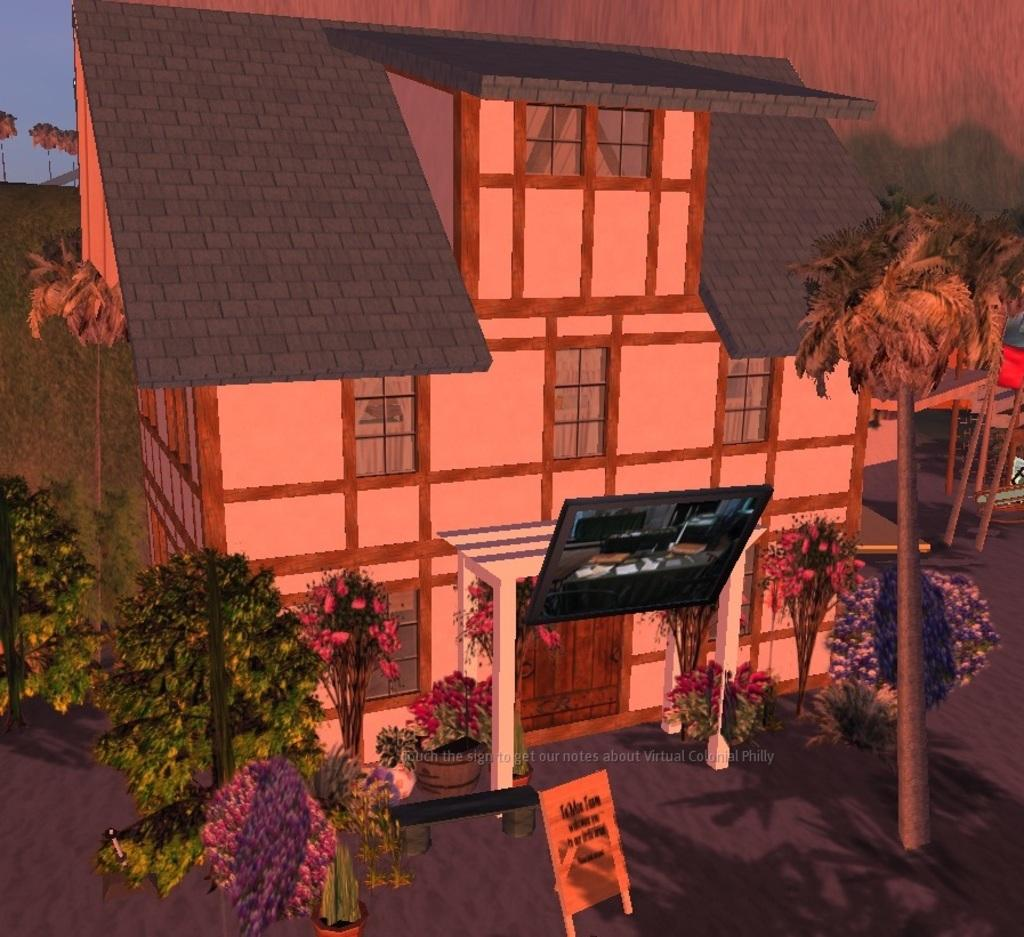What is the main subject of the image? The main subject of the image is an animated picture of a building. What features can be seen on the building? The building has windows and a door. What is present in the background of the image? There is a sign board and a group of trees in the background of the image. What can be seen above the trees and sign board in the image? The sky is visible in the background of the image. What type of appliance is being used to commit a crime in the image? There is no appliance or crime present in the image; it features an animated picture of a building with a sign board, trees, and the sky in the background. 